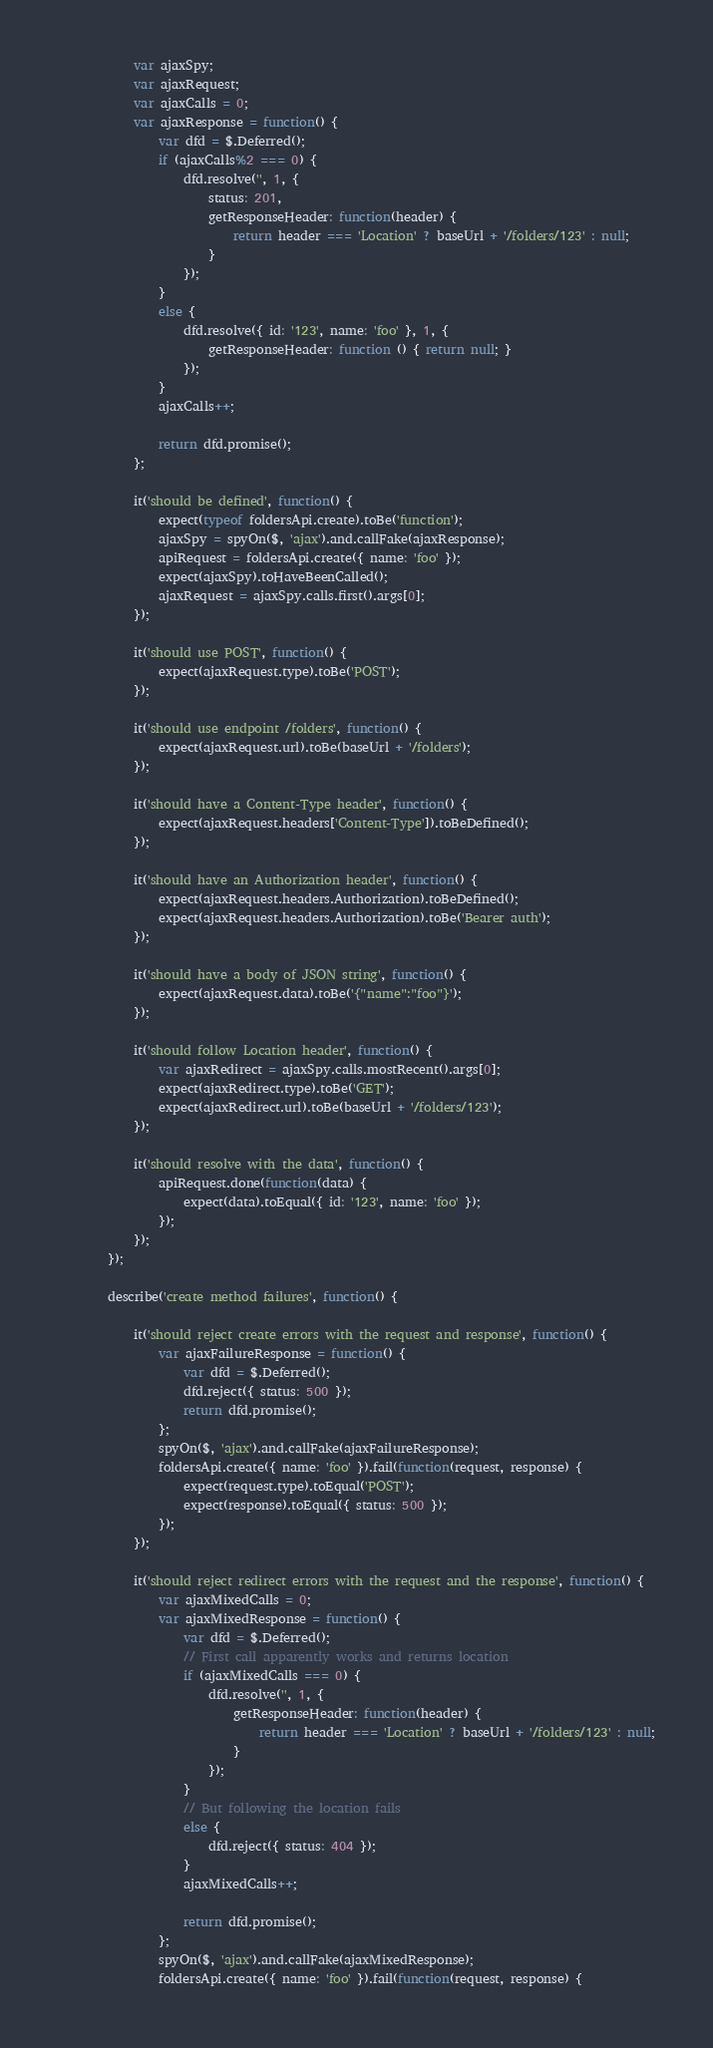Convert code to text. <code><loc_0><loc_0><loc_500><loc_500><_JavaScript_>            var ajaxSpy;
            var ajaxRequest;
            var ajaxCalls = 0;
            var ajaxResponse = function() {
                var dfd = $.Deferred();
                if (ajaxCalls%2 === 0) {
                    dfd.resolve('', 1, {
                        status: 201,
                        getResponseHeader: function(header) {
                            return header === 'Location' ? baseUrl + '/folders/123' : null;
                        }
                    });
                }
                else {
                    dfd.resolve({ id: '123', name: 'foo' }, 1, {
                        getResponseHeader: function () { return null; }
                    });
                }
                ajaxCalls++;

                return dfd.promise();
            };

            it('should be defined', function() {
                expect(typeof foldersApi.create).toBe('function');
                ajaxSpy = spyOn($, 'ajax').and.callFake(ajaxResponse);
                apiRequest = foldersApi.create({ name: 'foo' });
                expect(ajaxSpy).toHaveBeenCalled();
                ajaxRequest = ajaxSpy.calls.first().args[0];
            });

            it('should use POST', function() {
                expect(ajaxRequest.type).toBe('POST');
            });

            it('should use endpoint /folders', function() {
                expect(ajaxRequest.url).toBe(baseUrl + '/folders');
            });

            it('should have a Content-Type header', function() {
                expect(ajaxRequest.headers['Content-Type']).toBeDefined();
            });

            it('should have an Authorization header', function() {
                expect(ajaxRequest.headers.Authorization).toBeDefined();
                expect(ajaxRequest.headers.Authorization).toBe('Bearer auth');
            });

            it('should have a body of JSON string', function() {
                expect(ajaxRequest.data).toBe('{"name":"foo"}');
            });

            it('should follow Location header', function() {
                var ajaxRedirect = ajaxSpy.calls.mostRecent().args[0];
                expect(ajaxRedirect.type).toBe('GET');
                expect(ajaxRedirect.url).toBe(baseUrl + '/folders/123');
            });

            it('should resolve with the data', function() {
                apiRequest.done(function(data) {
                    expect(data).toEqual({ id: '123', name: 'foo' });
                });
            });
        });

        describe('create method failures', function() {

            it('should reject create errors with the request and response', function() {
                var ajaxFailureResponse = function() {
                    var dfd = $.Deferred();
                    dfd.reject({ status: 500 });
                    return dfd.promise();
                };
                spyOn($, 'ajax').and.callFake(ajaxFailureResponse);
                foldersApi.create({ name: 'foo' }).fail(function(request, response) {
                    expect(request.type).toEqual('POST');
                    expect(response).toEqual({ status: 500 });
                });
            });

            it('should reject redirect errors with the request and the response', function() {
                var ajaxMixedCalls = 0;
                var ajaxMixedResponse = function() {
                    var dfd = $.Deferred();
                    // First call apparently works and returns location
                    if (ajaxMixedCalls === 0) {
                        dfd.resolve('', 1, {
                            getResponseHeader: function(header) {
                                return header === 'Location' ? baseUrl + '/folders/123' : null;
                            }
                        });
                    }
                    // But following the location fails
                    else {
                        dfd.reject({ status: 404 });
                    }
                    ajaxMixedCalls++;

                    return dfd.promise();
                };
                spyOn($, 'ajax').and.callFake(ajaxMixedResponse);
                foldersApi.create({ name: 'foo' }).fail(function(request, response) {</code> 